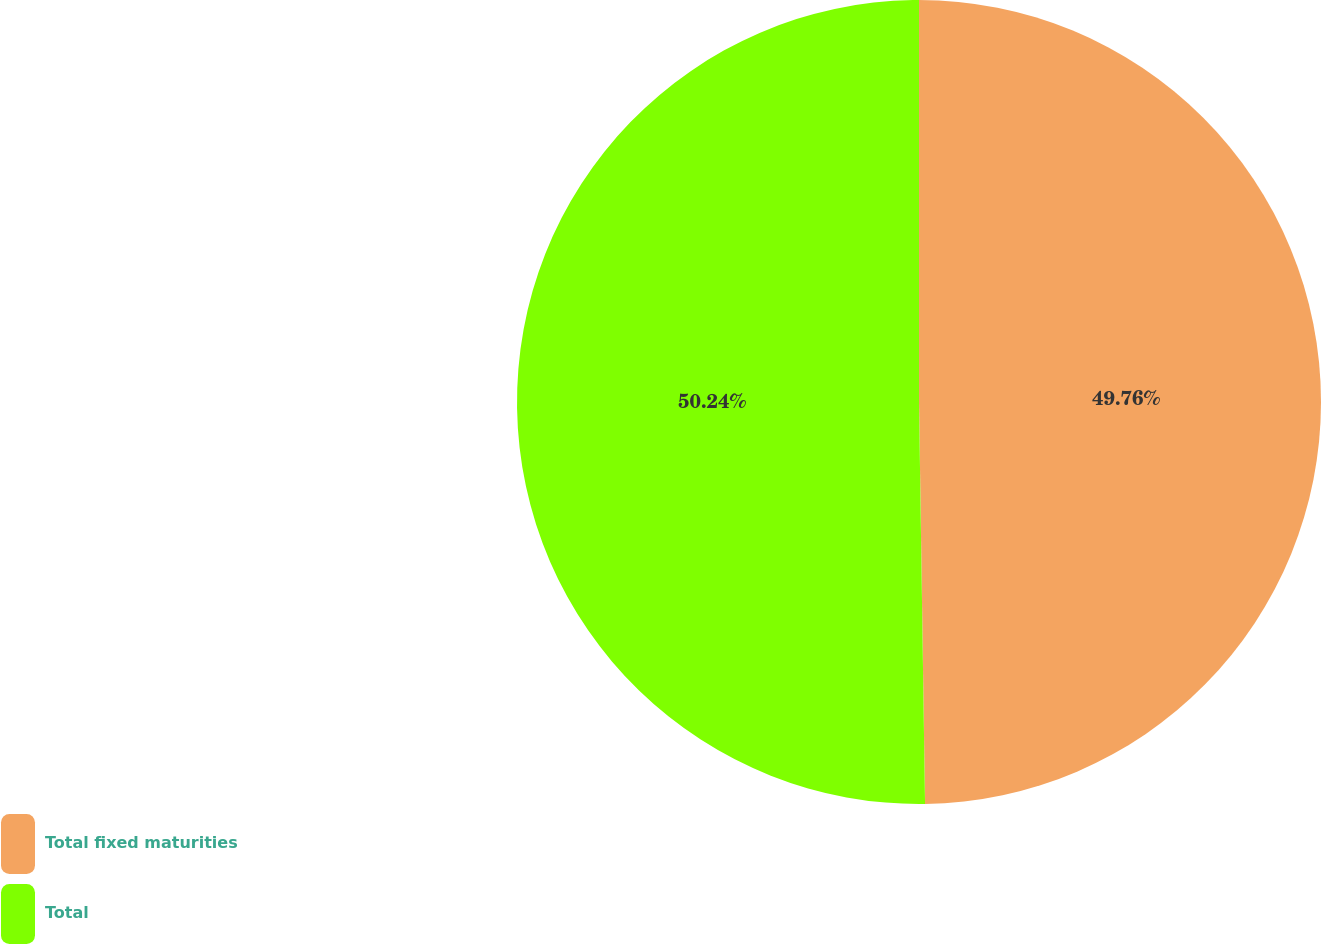Convert chart to OTSL. <chart><loc_0><loc_0><loc_500><loc_500><pie_chart><fcel>Total fixed maturities<fcel>Total<nl><fcel>49.76%<fcel>50.24%<nl></chart> 